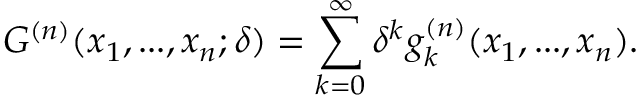<formula> <loc_0><loc_0><loc_500><loc_500>G ^ { ( n ) } ( x _ { 1 } , \dots , x _ { n } ; \delta ) = \sum _ { k = 0 } ^ { \infty } \delta ^ { k } g _ { k } ^ { ( n ) } ( x _ { 1 } , \dots , x _ { n } ) .</formula> 